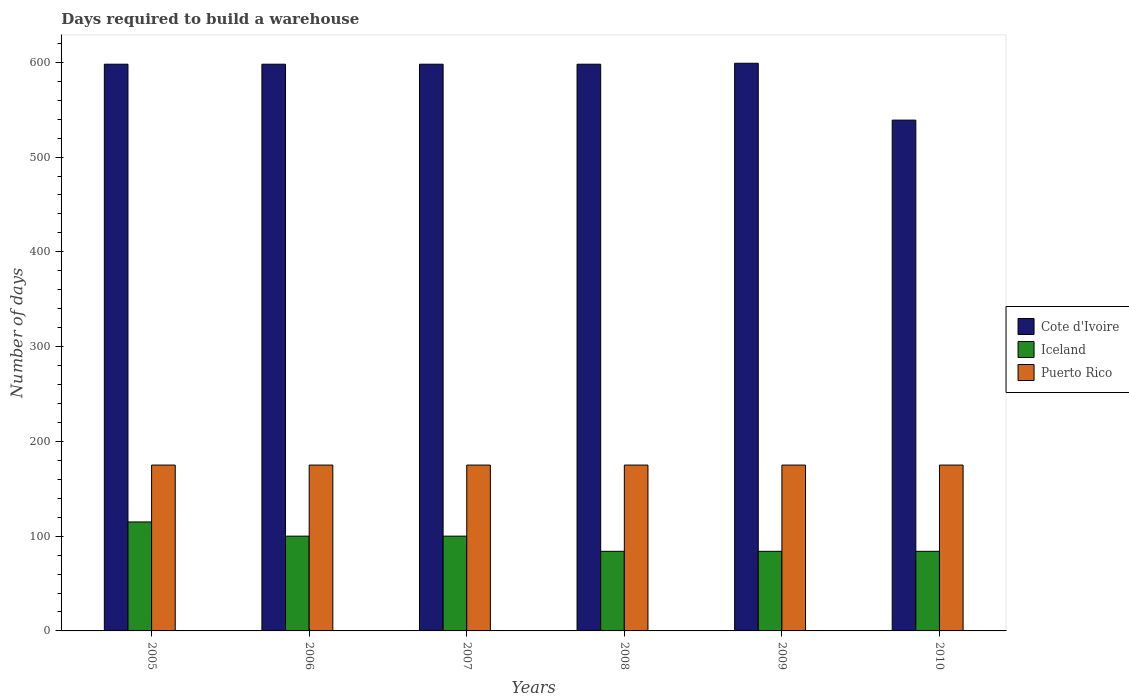How many groups of bars are there?
Provide a succinct answer. 6. Are the number of bars on each tick of the X-axis equal?
Provide a short and direct response. Yes. How many bars are there on the 4th tick from the right?
Offer a very short reply. 3. What is the days required to build a warehouse in in Iceland in 2009?
Keep it short and to the point. 84. Across all years, what is the maximum days required to build a warehouse in in Puerto Rico?
Ensure brevity in your answer.  175. Across all years, what is the minimum days required to build a warehouse in in Cote d'Ivoire?
Your answer should be compact. 539. In which year was the days required to build a warehouse in in Puerto Rico maximum?
Provide a succinct answer. 2005. What is the total days required to build a warehouse in in Iceland in the graph?
Give a very brief answer. 567. What is the difference between the days required to build a warehouse in in Cote d'Ivoire in 2006 and that in 2009?
Give a very brief answer. -1. What is the difference between the days required to build a warehouse in in Cote d'Ivoire in 2007 and the days required to build a warehouse in in Puerto Rico in 2010?
Keep it short and to the point. 423. What is the average days required to build a warehouse in in Iceland per year?
Make the answer very short. 94.5. In the year 2008, what is the difference between the days required to build a warehouse in in Iceland and days required to build a warehouse in in Puerto Rico?
Give a very brief answer. -91. In how many years, is the days required to build a warehouse in in Iceland greater than 420 days?
Your response must be concise. 0. What is the ratio of the days required to build a warehouse in in Cote d'Ivoire in 2007 to that in 2010?
Offer a very short reply. 1.11. Is the days required to build a warehouse in in Iceland in 2005 less than that in 2006?
Provide a succinct answer. No. What is the difference between the highest and the second highest days required to build a warehouse in in Puerto Rico?
Your answer should be very brief. 0. What is the difference between the highest and the lowest days required to build a warehouse in in Cote d'Ivoire?
Your response must be concise. 60. In how many years, is the days required to build a warehouse in in Puerto Rico greater than the average days required to build a warehouse in in Puerto Rico taken over all years?
Your response must be concise. 0. Is the sum of the days required to build a warehouse in in Cote d'Ivoire in 2006 and 2007 greater than the maximum days required to build a warehouse in in Puerto Rico across all years?
Your answer should be very brief. Yes. What does the 1st bar from the left in 2009 represents?
Provide a short and direct response. Cote d'Ivoire. What does the 3rd bar from the right in 2008 represents?
Ensure brevity in your answer.  Cote d'Ivoire. How many bars are there?
Your answer should be compact. 18. Are all the bars in the graph horizontal?
Keep it short and to the point. No. What is the difference between two consecutive major ticks on the Y-axis?
Offer a terse response. 100. Does the graph contain any zero values?
Your response must be concise. No. Does the graph contain grids?
Offer a very short reply. No. Where does the legend appear in the graph?
Make the answer very short. Center right. How are the legend labels stacked?
Ensure brevity in your answer.  Vertical. What is the title of the graph?
Offer a terse response. Days required to build a warehouse. Does "Lower middle income" appear as one of the legend labels in the graph?
Your answer should be compact. No. What is the label or title of the Y-axis?
Provide a succinct answer. Number of days. What is the Number of days of Cote d'Ivoire in 2005?
Your answer should be very brief. 598. What is the Number of days in Iceland in 2005?
Your response must be concise. 115. What is the Number of days of Puerto Rico in 2005?
Your answer should be very brief. 175. What is the Number of days of Cote d'Ivoire in 2006?
Provide a succinct answer. 598. What is the Number of days in Iceland in 2006?
Offer a terse response. 100. What is the Number of days in Puerto Rico in 2006?
Your answer should be very brief. 175. What is the Number of days of Cote d'Ivoire in 2007?
Your response must be concise. 598. What is the Number of days in Puerto Rico in 2007?
Provide a succinct answer. 175. What is the Number of days in Cote d'Ivoire in 2008?
Your answer should be compact. 598. What is the Number of days of Iceland in 2008?
Your response must be concise. 84. What is the Number of days of Puerto Rico in 2008?
Your response must be concise. 175. What is the Number of days of Cote d'Ivoire in 2009?
Ensure brevity in your answer.  599. What is the Number of days of Iceland in 2009?
Offer a very short reply. 84. What is the Number of days of Puerto Rico in 2009?
Keep it short and to the point. 175. What is the Number of days of Cote d'Ivoire in 2010?
Keep it short and to the point. 539. What is the Number of days in Puerto Rico in 2010?
Give a very brief answer. 175. Across all years, what is the maximum Number of days of Cote d'Ivoire?
Keep it short and to the point. 599. Across all years, what is the maximum Number of days in Iceland?
Give a very brief answer. 115. Across all years, what is the maximum Number of days of Puerto Rico?
Your response must be concise. 175. Across all years, what is the minimum Number of days in Cote d'Ivoire?
Give a very brief answer. 539. Across all years, what is the minimum Number of days in Puerto Rico?
Provide a succinct answer. 175. What is the total Number of days in Cote d'Ivoire in the graph?
Ensure brevity in your answer.  3530. What is the total Number of days in Iceland in the graph?
Your response must be concise. 567. What is the total Number of days in Puerto Rico in the graph?
Your response must be concise. 1050. What is the difference between the Number of days of Iceland in 2005 and that in 2006?
Offer a very short reply. 15. What is the difference between the Number of days of Puerto Rico in 2005 and that in 2006?
Provide a succinct answer. 0. What is the difference between the Number of days in Puerto Rico in 2005 and that in 2007?
Provide a short and direct response. 0. What is the difference between the Number of days of Iceland in 2005 and that in 2009?
Give a very brief answer. 31. What is the difference between the Number of days in Puerto Rico in 2005 and that in 2009?
Provide a short and direct response. 0. What is the difference between the Number of days of Cote d'Ivoire in 2005 and that in 2010?
Your response must be concise. 59. What is the difference between the Number of days in Puerto Rico in 2005 and that in 2010?
Provide a succinct answer. 0. What is the difference between the Number of days of Cote d'Ivoire in 2006 and that in 2007?
Provide a succinct answer. 0. What is the difference between the Number of days in Cote d'Ivoire in 2006 and that in 2008?
Provide a short and direct response. 0. What is the difference between the Number of days in Puerto Rico in 2006 and that in 2008?
Your answer should be very brief. 0. What is the difference between the Number of days of Iceland in 2006 and that in 2009?
Your answer should be compact. 16. What is the difference between the Number of days of Puerto Rico in 2006 and that in 2009?
Ensure brevity in your answer.  0. What is the difference between the Number of days of Cote d'Ivoire in 2006 and that in 2010?
Ensure brevity in your answer.  59. What is the difference between the Number of days of Iceland in 2006 and that in 2010?
Your answer should be compact. 16. What is the difference between the Number of days in Cote d'Ivoire in 2007 and that in 2008?
Give a very brief answer. 0. What is the difference between the Number of days in Iceland in 2007 and that in 2008?
Ensure brevity in your answer.  16. What is the difference between the Number of days of Cote d'Ivoire in 2007 and that in 2009?
Offer a terse response. -1. What is the difference between the Number of days of Cote d'Ivoire in 2007 and that in 2010?
Keep it short and to the point. 59. What is the difference between the Number of days of Iceland in 2008 and that in 2009?
Keep it short and to the point. 0. What is the difference between the Number of days of Puerto Rico in 2008 and that in 2009?
Make the answer very short. 0. What is the difference between the Number of days of Cote d'Ivoire in 2008 and that in 2010?
Offer a terse response. 59. What is the difference between the Number of days of Cote d'Ivoire in 2009 and that in 2010?
Offer a very short reply. 60. What is the difference between the Number of days of Iceland in 2009 and that in 2010?
Your answer should be compact. 0. What is the difference between the Number of days in Cote d'Ivoire in 2005 and the Number of days in Iceland in 2006?
Give a very brief answer. 498. What is the difference between the Number of days of Cote d'Ivoire in 2005 and the Number of days of Puerto Rico in 2006?
Your answer should be very brief. 423. What is the difference between the Number of days of Iceland in 2005 and the Number of days of Puerto Rico in 2006?
Provide a succinct answer. -60. What is the difference between the Number of days of Cote d'Ivoire in 2005 and the Number of days of Iceland in 2007?
Ensure brevity in your answer.  498. What is the difference between the Number of days in Cote d'Ivoire in 2005 and the Number of days in Puerto Rico in 2007?
Your answer should be very brief. 423. What is the difference between the Number of days of Iceland in 2005 and the Number of days of Puerto Rico in 2007?
Offer a very short reply. -60. What is the difference between the Number of days of Cote d'Ivoire in 2005 and the Number of days of Iceland in 2008?
Provide a short and direct response. 514. What is the difference between the Number of days of Cote d'Ivoire in 2005 and the Number of days of Puerto Rico in 2008?
Ensure brevity in your answer.  423. What is the difference between the Number of days in Iceland in 2005 and the Number of days in Puerto Rico in 2008?
Make the answer very short. -60. What is the difference between the Number of days in Cote d'Ivoire in 2005 and the Number of days in Iceland in 2009?
Give a very brief answer. 514. What is the difference between the Number of days in Cote d'Ivoire in 2005 and the Number of days in Puerto Rico in 2009?
Provide a short and direct response. 423. What is the difference between the Number of days of Iceland in 2005 and the Number of days of Puerto Rico in 2009?
Your response must be concise. -60. What is the difference between the Number of days in Cote d'Ivoire in 2005 and the Number of days in Iceland in 2010?
Your answer should be compact. 514. What is the difference between the Number of days in Cote d'Ivoire in 2005 and the Number of days in Puerto Rico in 2010?
Make the answer very short. 423. What is the difference between the Number of days in Iceland in 2005 and the Number of days in Puerto Rico in 2010?
Provide a short and direct response. -60. What is the difference between the Number of days of Cote d'Ivoire in 2006 and the Number of days of Iceland in 2007?
Provide a succinct answer. 498. What is the difference between the Number of days in Cote d'Ivoire in 2006 and the Number of days in Puerto Rico in 2007?
Keep it short and to the point. 423. What is the difference between the Number of days in Iceland in 2006 and the Number of days in Puerto Rico in 2007?
Provide a short and direct response. -75. What is the difference between the Number of days of Cote d'Ivoire in 2006 and the Number of days of Iceland in 2008?
Offer a terse response. 514. What is the difference between the Number of days of Cote d'Ivoire in 2006 and the Number of days of Puerto Rico in 2008?
Offer a very short reply. 423. What is the difference between the Number of days in Iceland in 2006 and the Number of days in Puerto Rico in 2008?
Make the answer very short. -75. What is the difference between the Number of days in Cote d'Ivoire in 2006 and the Number of days in Iceland in 2009?
Provide a succinct answer. 514. What is the difference between the Number of days of Cote d'Ivoire in 2006 and the Number of days of Puerto Rico in 2009?
Provide a short and direct response. 423. What is the difference between the Number of days in Iceland in 2006 and the Number of days in Puerto Rico in 2009?
Your answer should be very brief. -75. What is the difference between the Number of days in Cote d'Ivoire in 2006 and the Number of days in Iceland in 2010?
Provide a succinct answer. 514. What is the difference between the Number of days of Cote d'Ivoire in 2006 and the Number of days of Puerto Rico in 2010?
Ensure brevity in your answer.  423. What is the difference between the Number of days of Iceland in 2006 and the Number of days of Puerto Rico in 2010?
Provide a succinct answer. -75. What is the difference between the Number of days in Cote d'Ivoire in 2007 and the Number of days in Iceland in 2008?
Your answer should be very brief. 514. What is the difference between the Number of days of Cote d'Ivoire in 2007 and the Number of days of Puerto Rico in 2008?
Your answer should be very brief. 423. What is the difference between the Number of days in Iceland in 2007 and the Number of days in Puerto Rico in 2008?
Your answer should be very brief. -75. What is the difference between the Number of days in Cote d'Ivoire in 2007 and the Number of days in Iceland in 2009?
Give a very brief answer. 514. What is the difference between the Number of days of Cote d'Ivoire in 2007 and the Number of days of Puerto Rico in 2009?
Your response must be concise. 423. What is the difference between the Number of days in Iceland in 2007 and the Number of days in Puerto Rico in 2009?
Provide a succinct answer. -75. What is the difference between the Number of days in Cote d'Ivoire in 2007 and the Number of days in Iceland in 2010?
Give a very brief answer. 514. What is the difference between the Number of days in Cote d'Ivoire in 2007 and the Number of days in Puerto Rico in 2010?
Ensure brevity in your answer.  423. What is the difference between the Number of days of Iceland in 2007 and the Number of days of Puerto Rico in 2010?
Your answer should be very brief. -75. What is the difference between the Number of days in Cote d'Ivoire in 2008 and the Number of days in Iceland in 2009?
Give a very brief answer. 514. What is the difference between the Number of days of Cote d'Ivoire in 2008 and the Number of days of Puerto Rico in 2009?
Provide a short and direct response. 423. What is the difference between the Number of days of Iceland in 2008 and the Number of days of Puerto Rico in 2009?
Provide a short and direct response. -91. What is the difference between the Number of days in Cote d'Ivoire in 2008 and the Number of days in Iceland in 2010?
Your response must be concise. 514. What is the difference between the Number of days in Cote d'Ivoire in 2008 and the Number of days in Puerto Rico in 2010?
Give a very brief answer. 423. What is the difference between the Number of days in Iceland in 2008 and the Number of days in Puerto Rico in 2010?
Offer a very short reply. -91. What is the difference between the Number of days of Cote d'Ivoire in 2009 and the Number of days of Iceland in 2010?
Offer a terse response. 515. What is the difference between the Number of days of Cote d'Ivoire in 2009 and the Number of days of Puerto Rico in 2010?
Your answer should be very brief. 424. What is the difference between the Number of days in Iceland in 2009 and the Number of days in Puerto Rico in 2010?
Your answer should be very brief. -91. What is the average Number of days of Cote d'Ivoire per year?
Keep it short and to the point. 588.33. What is the average Number of days of Iceland per year?
Provide a short and direct response. 94.5. What is the average Number of days in Puerto Rico per year?
Keep it short and to the point. 175. In the year 2005, what is the difference between the Number of days of Cote d'Ivoire and Number of days of Iceland?
Ensure brevity in your answer.  483. In the year 2005, what is the difference between the Number of days of Cote d'Ivoire and Number of days of Puerto Rico?
Offer a very short reply. 423. In the year 2005, what is the difference between the Number of days of Iceland and Number of days of Puerto Rico?
Your response must be concise. -60. In the year 2006, what is the difference between the Number of days in Cote d'Ivoire and Number of days in Iceland?
Make the answer very short. 498. In the year 2006, what is the difference between the Number of days in Cote d'Ivoire and Number of days in Puerto Rico?
Your response must be concise. 423. In the year 2006, what is the difference between the Number of days of Iceland and Number of days of Puerto Rico?
Offer a very short reply. -75. In the year 2007, what is the difference between the Number of days in Cote d'Ivoire and Number of days in Iceland?
Your answer should be very brief. 498. In the year 2007, what is the difference between the Number of days of Cote d'Ivoire and Number of days of Puerto Rico?
Offer a terse response. 423. In the year 2007, what is the difference between the Number of days in Iceland and Number of days in Puerto Rico?
Your response must be concise. -75. In the year 2008, what is the difference between the Number of days in Cote d'Ivoire and Number of days in Iceland?
Provide a short and direct response. 514. In the year 2008, what is the difference between the Number of days in Cote d'Ivoire and Number of days in Puerto Rico?
Your answer should be compact. 423. In the year 2008, what is the difference between the Number of days in Iceland and Number of days in Puerto Rico?
Your answer should be compact. -91. In the year 2009, what is the difference between the Number of days in Cote d'Ivoire and Number of days in Iceland?
Provide a short and direct response. 515. In the year 2009, what is the difference between the Number of days in Cote d'Ivoire and Number of days in Puerto Rico?
Ensure brevity in your answer.  424. In the year 2009, what is the difference between the Number of days of Iceland and Number of days of Puerto Rico?
Keep it short and to the point. -91. In the year 2010, what is the difference between the Number of days in Cote d'Ivoire and Number of days in Iceland?
Keep it short and to the point. 455. In the year 2010, what is the difference between the Number of days of Cote d'Ivoire and Number of days of Puerto Rico?
Offer a terse response. 364. In the year 2010, what is the difference between the Number of days in Iceland and Number of days in Puerto Rico?
Your answer should be compact. -91. What is the ratio of the Number of days in Cote d'Ivoire in 2005 to that in 2006?
Your answer should be very brief. 1. What is the ratio of the Number of days of Iceland in 2005 to that in 2006?
Your response must be concise. 1.15. What is the ratio of the Number of days of Cote d'Ivoire in 2005 to that in 2007?
Offer a very short reply. 1. What is the ratio of the Number of days in Iceland in 2005 to that in 2007?
Make the answer very short. 1.15. What is the ratio of the Number of days in Iceland in 2005 to that in 2008?
Offer a very short reply. 1.37. What is the ratio of the Number of days of Puerto Rico in 2005 to that in 2008?
Provide a succinct answer. 1. What is the ratio of the Number of days of Iceland in 2005 to that in 2009?
Give a very brief answer. 1.37. What is the ratio of the Number of days of Cote d'Ivoire in 2005 to that in 2010?
Ensure brevity in your answer.  1.11. What is the ratio of the Number of days of Iceland in 2005 to that in 2010?
Offer a very short reply. 1.37. What is the ratio of the Number of days of Puerto Rico in 2006 to that in 2007?
Your answer should be very brief. 1. What is the ratio of the Number of days in Iceland in 2006 to that in 2008?
Give a very brief answer. 1.19. What is the ratio of the Number of days in Cote d'Ivoire in 2006 to that in 2009?
Give a very brief answer. 1. What is the ratio of the Number of days of Iceland in 2006 to that in 2009?
Offer a terse response. 1.19. What is the ratio of the Number of days in Puerto Rico in 2006 to that in 2009?
Offer a very short reply. 1. What is the ratio of the Number of days in Cote d'Ivoire in 2006 to that in 2010?
Your answer should be compact. 1.11. What is the ratio of the Number of days of Iceland in 2006 to that in 2010?
Keep it short and to the point. 1.19. What is the ratio of the Number of days of Puerto Rico in 2006 to that in 2010?
Your answer should be very brief. 1. What is the ratio of the Number of days of Cote d'Ivoire in 2007 to that in 2008?
Your response must be concise. 1. What is the ratio of the Number of days of Iceland in 2007 to that in 2008?
Provide a succinct answer. 1.19. What is the ratio of the Number of days in Puerto Rico in 2007 to that in 2008?
Keep it short and to the point. 1. What is the ratio of the Number of days of Cote d'Ivoire in 2007 to that in 2009?
Offer a terse response. 1. What is the ratio of the Number of days in Iceland in 2007 to that in 2009?
Provide a succinct answer. 1.19. What is the ratio of the Number of days in Puerto Rico in 2007 to that in 2009?
Give a very brief answer. 1. What is the ratio of the Number of days of Cote d'Ivoire in 2007 to that in 2010?
Provide a short and direct response. 1.11. What is the ratio of the Number of days of Iceland in 2007 to that in 2010?
Make the answer very short. 1.19. What is the ratio of the Number of days of Puerto Rico in 2007 to that in 2010?
Make the answer very short. 1. What is the ratio of the Number of days of Cote d'Ivoire in 2008 to that in 2009?
Keep it short and to the point. 1. What is the ratio of the Number of days of Puerto Rico in 2008 to that in 2009?
Your response must be concise. 1. What is the ratio of the Number of days in Cote d'Ivoire in 2008 to that in 2010?
Offer a terse response. 1.11. What is the ratio of the Number of days in Iceland in 2008 to that in 2010?
Provide a succinct answer. 1. What is the ratio of the Number of days in Cote d'Ivoire in 2009 to that in 2010?
Make the answer very short. 1.11. What is the ratio of the Number of days of Iceland in 2009 to that in 2010?
Offer a terse response. 1. What is the ratio of the Number of days of Puerto Rico in 2009 to that in 2010?
Your answer should be very brief. 1. What is the difference between the highest and the second highest Number of days in Iceland?
Your response must be concise. 15. What is the difference between the highest and the lowest Number of days of Iceland?
Make the answer very short. 31. 